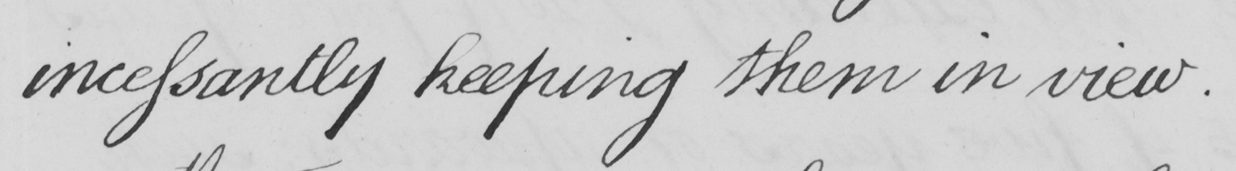What does this handwritten line say? incessantly keeping them in view . 